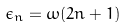Convert formula to latex. <formula><loc_0><loc_0><loc_500><loc_500>\epsilon _ { n } = \omega ( 2 n + 1 )</formula> 